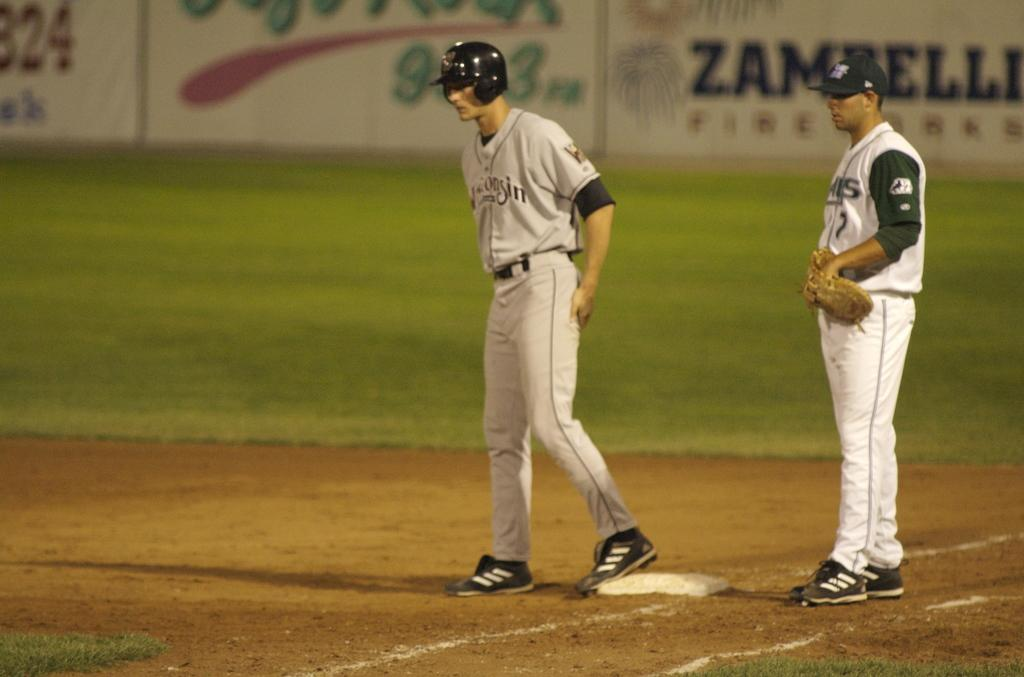Provide a one-sentence caption for the provided image. A player from Wisconsin stands on base, ready to run. 